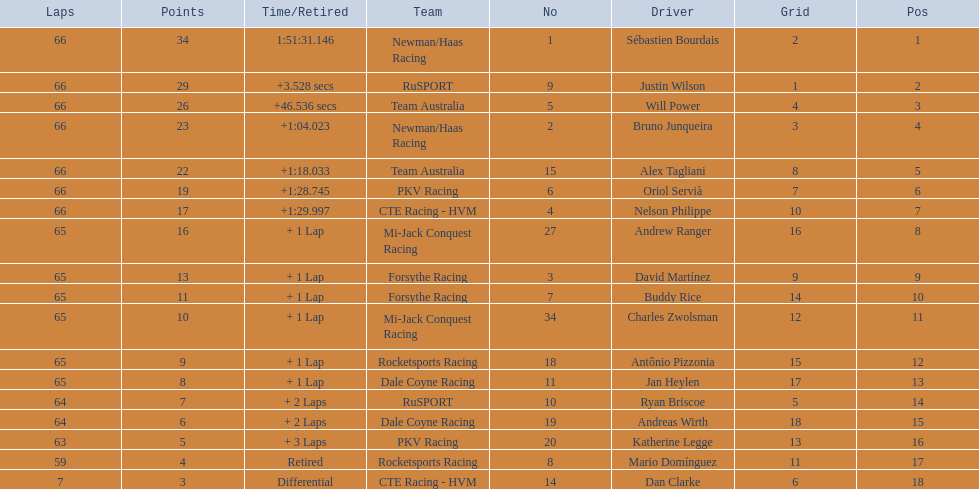Who are all the drivers? Sébastien Bourdais, Justin Wilson, Will Power, Bruno Junqueira, Alex Tagliani, Oriol Servià, Nelson Philippe, Andrew Ranger, David Martínez, Buddy Rice, Charles Zwolsman, Antônio Pizzonia, Jan Heylen, Ryan Briscoe, Andreas Wirth, Katherine Legge, Mario Domínguez, Dan Clarke. What position did they reach? 1, 2, 3, 4, 5, 6, 7, 8, 9, 10, 11, 12, 13, 14, 15, 16, 17, 18. What is the number for each driver? 1, 9, 5, 2, 15, 6, 4, 27, 3, 7, 34, 18, 11, 10, 19, 20, 8, 14. And which player's number and position match? Sébastien Bourdais. 